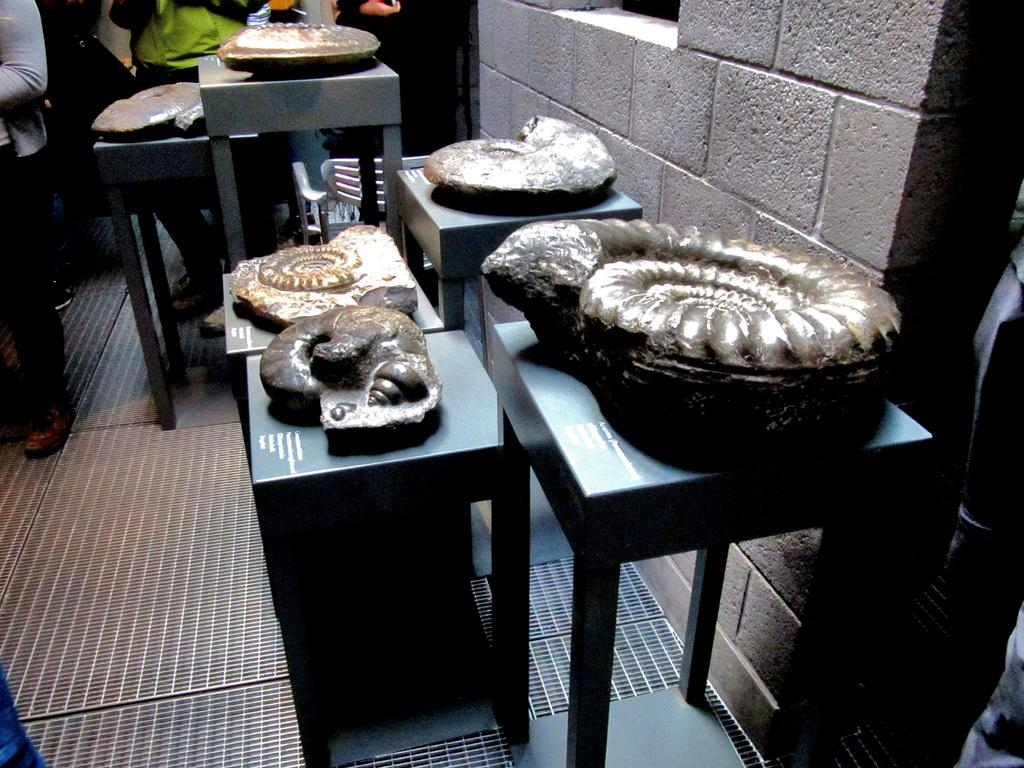Who or what can be seen in the image? There are people in the image. What else is visible in the image besides the people? There are objects placed on tables in the image. What is located at the right side of the image? There is a wall at the right side of the image. What type of fish can be seen swimming near the people in the image? There are no fish present in the image; it features people and objects on tables. How many dimes are visible on the tables in the image? There is no mention of dimes in the image; only people and objects are visible. 